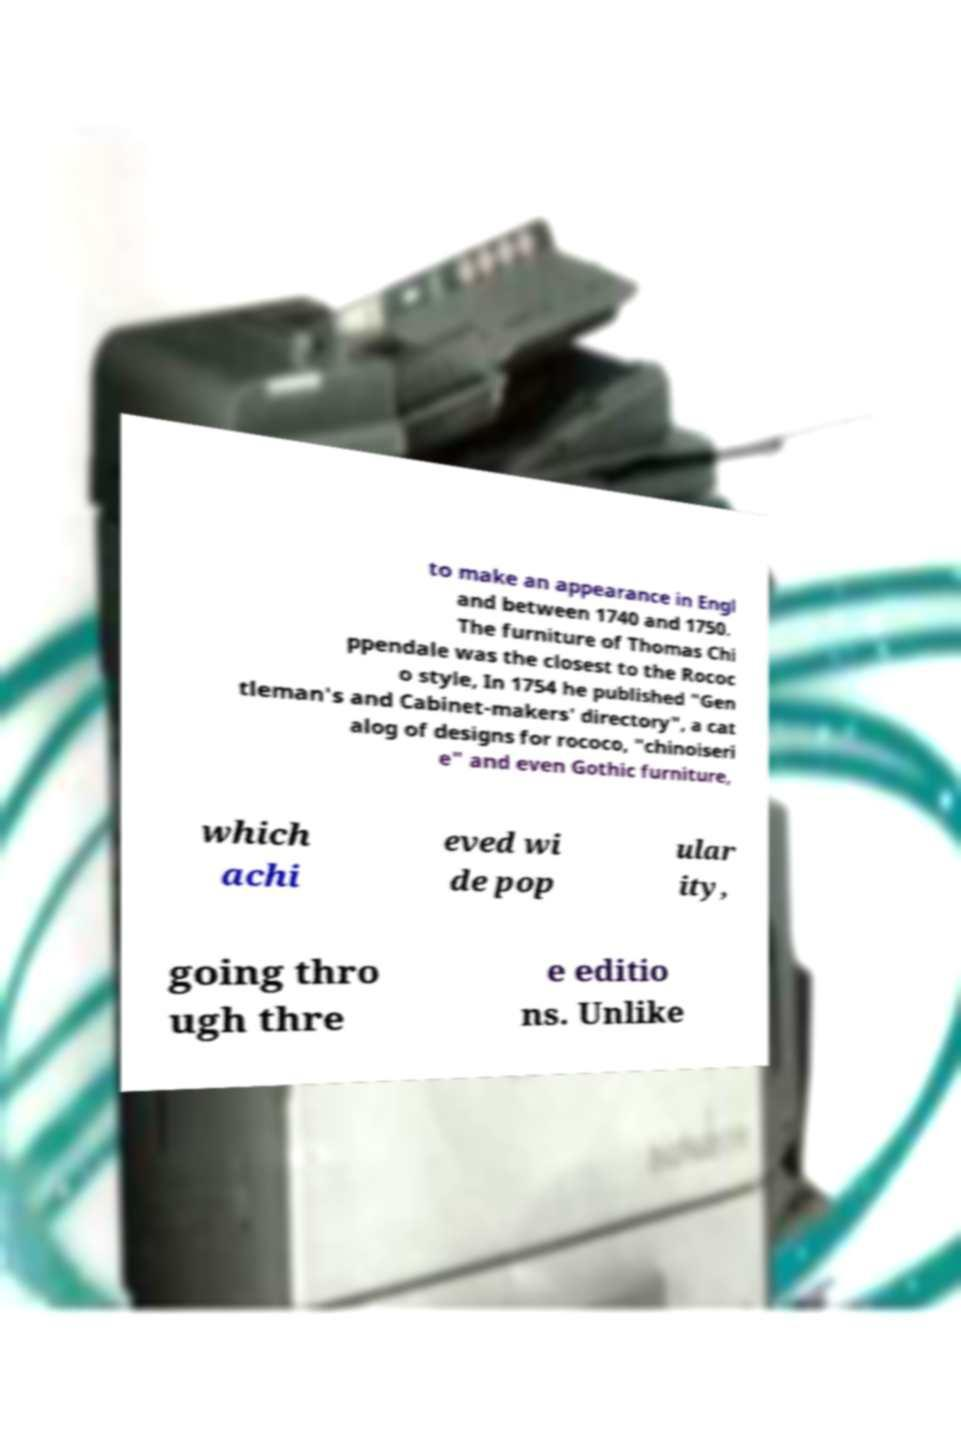Can you accurately transcribe the text from the provided image for me? to make an appearance in Engl and between 1740 and 1750. The furniture of Thomas Chi ppendale was the closest to the Rococ o style, In 1754 he published "Gen tleman's and Cabinet-makers' directory", a cat alog of designs for rococo, "chinoiseri e" and even Gothic furniture, which achi eved wi de pop ular ity, going thro ugh thre e editio ns. Unlike 